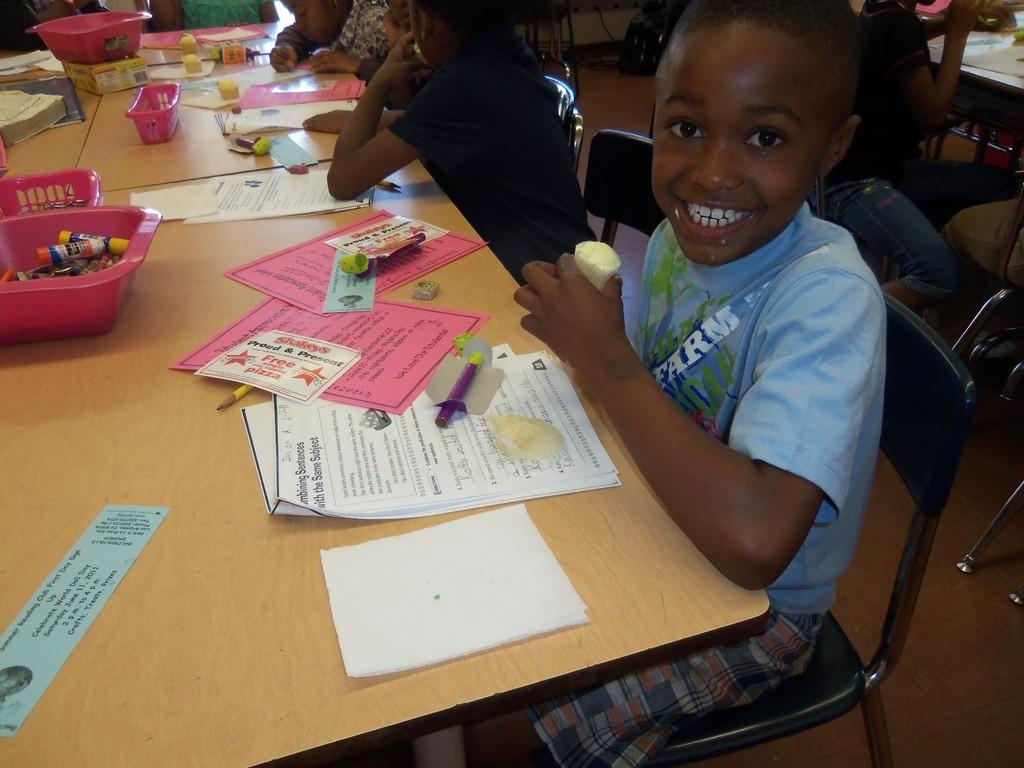How many kids are in the image? There is a group of kids in the image, but the exact number cannot be determined from the provided facts. Where are the kids located in the image? The kids are on the floor in the image. What can be seen in front of the kids? There are tables in front of the kids. What is on the tables? Baskets, papers, sketch pens, pencils, and other objects are present on the tables. What type of surprise is hidden in the dress of the kid in the image? There is no dress present in the image, and therefore no surprise can be hidden in it. 